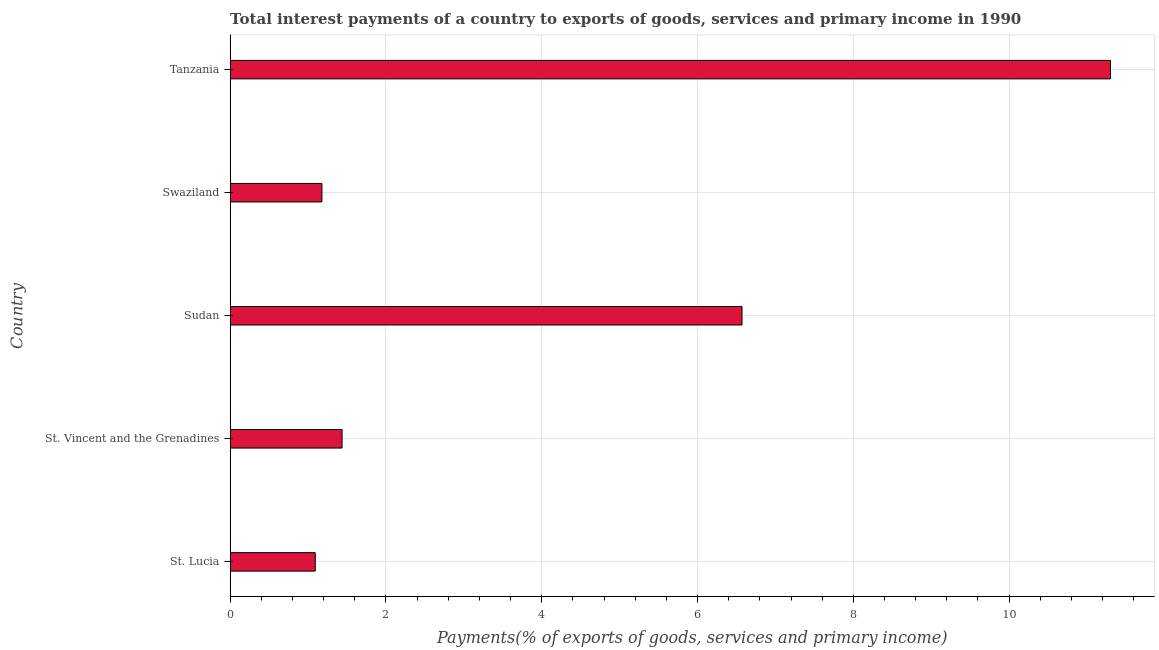Does the graph contain any zero values?
Provide a succinct answer. No. What is the title of the graph?
Provide a short and direct response. Total interest payments of a country to exports of goods, services and primary income in 1990. What is the label or title of the X-axis?
Provide a short and direct response. Payments(% of exports of goods, services and primary income). What is the label or title of the Y-axis?
Offer a very short reply. Country. What is the total interest payments on external debt in Swaziland?
Keep it short and to the point. 1.18. Across all countries, what is the maximum total interest payments on external debt?
Your response must be concise. 11.3. Across all countries, what is the minimum total interest payments on external debt?
Your response must be concise. 1.09. In which country was the total interest payments on external debt maximum?
Give a very brief answer. Tanzania. In which country was the total interest payments on external debt minimum?
Your response must be concise. St. Lucia. What is the sum of the total interest payments on external debt?
Provide a short and direct response. 21.58. What is the difference between the total interest payments on external debt in St. Vincent and the Grenadines and Sudan?
Your answer should be compact. -5.13. What is the average total interest payments on external debt per country?
Your answer should be very brief. 4.32. What is the median total interest payments on external debt?
Keep it short and to the point. 1.44. What is the ratio of the total interest payments on external debt in Sudan to that in Tanzania?
Your response must be concise. 0.58. Is the total interest payments on external debt in Swaziland less than that in Tanzania?
Offer a very short reply. Yes. Is the difference between the total interest payments on external debt in Swaziland and Tanzania greater than the difference between any two countries?
Give a very brief answer. No. What is the difference between the highest and the second highest total interest payments on external debt?
Your answer should be compact. 4.73. What is the difference between the highest and the lowest total interest payments on external debt?
Your response must be concise. 10.21. How many bars are there?
Keep it short and to the point. 5. What is the difference between two consecutive major ticks on the X-axis?
Ensure brevity in your answer.  2. What is the Payments(% of exports of goods, services and primary income) of St. Lucia?
Your answer should be very brief. 1.09. What is the Payments(% of exports of goods, services and primary income) in St. Vincent and the Grenadines?
Your answer should be very brief. 1.44. What is the Payments(% of exports of goods, services and primary income) in Sudan?
Offer a terse response. 6.57. What is the Payments(% of exports of goods, services and primary income) in Swaziland?
Ensure brevity in your answer.  1.18. What is the Payments(% of exports of goods, services and primary income) of Tanzania?
Offer a terse response. 11.3. What is the difference between the Payments(% of exports of goods, services and primary income) in St. Lucia and St. Vincent and the Grenadines?
Provide a short and direct response. -0.34. What is the difference between the Payments(% of exports of goods, services and primary income) in St. Lucia and Sudan?
Offer a very short reply. -5.48. What is the difference between the Payments(% of exports of goods, services and primary income) in St. Lucia and Swaziland?
Make the answer very short. -0.09. What is the difference between the Payments(% of exports of goods, services and primary income) in St. Lucia and Tanzania?
Your answer should be very brief. -10.21. What is the difference between the Payments(% of exports of goods, services and primary income) in St. Vincent and the Grenadines and Sudan?
Provide a short and direct response. -5.13. What is the difference between the Payments(% of exports of goods, services and primary income) in St. Vincent and the Grenadines and Swaziland?
Ensure brevity in your answer.  0.26. What is the difference between the Payments(% of exports of goods, services and primary income) in St. Vincent and the Grenadines and Tanzania?
Keep it short and to the point. -9.86. What is the difference between the Payments(% of exports of goods, services and primary income) in Sudan and Swaziland?
Your answer should be compact. 5.39. What is the difference between the Payments(% of exports of goods, services and primary income) in Sudan and Tanzania?
Your answer should be compact. -4.73. What is the difference between the Payments(% of exports of goods, services and primary income) in Swaziland and Tanzania?
Provide a succinct answer. -10.12. What is the ratio of the Payments(% of exports of goods, services and primary income) in St. Lucia to that in St. Vincent and the Grenadines?
Provide a succinct answer. 0.76. What is the ratio of the Payments(% of exports of goods, services and primary income) in St. Lucia to that in Sudan?
Offer a very short reply. 0.17. What is the ratio of the Payments(% of exports of goods, services and primary income) in St. Lucia to that in Swaziland?
Provide a short and direct response. 0.93. What is the ratio of the Payments(% of exports of goods, services and primary income) in St. Lucia to that in Tanzania?
Give a very brief answer. 0.1. What is the ratio of the Payments(% of exports of goods, services and primary income) in St. Vincent and the Grenadines to that in Sudan?
Your answer should be very brief. 0.22. What is the ratio of the Payments(% of exports of goods, services and primary income) in St. Vincent and the Grenadines to that in Swaziland?
Provide a succinct answer. 1.22. What is the ratio of the Payments(% of exports of goods, services and primary income) in St. Vincent and the Grenadines to that in Tanzania?
Keep it short and to the point. 0.13. What is the ratio of the Payments(% of exports of goods, services and primary income) in Sudan to that in Swaziland?
Offer a terse response. 5.58. What is the ratio of the Payments(% of exports of goods, services and primary income) in Sudan to that in Tanzania?
Offer a terse response. 0.58. What is the ratio of the Payments(% of exports of goods, services and primary income) in Swaziland to that in Tanzania?
Your answer should be very brief. 0.1. 